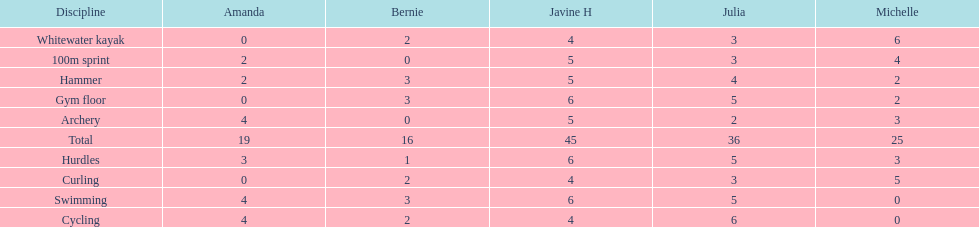What is the last discipline listed on this chart? 100m sprint. 